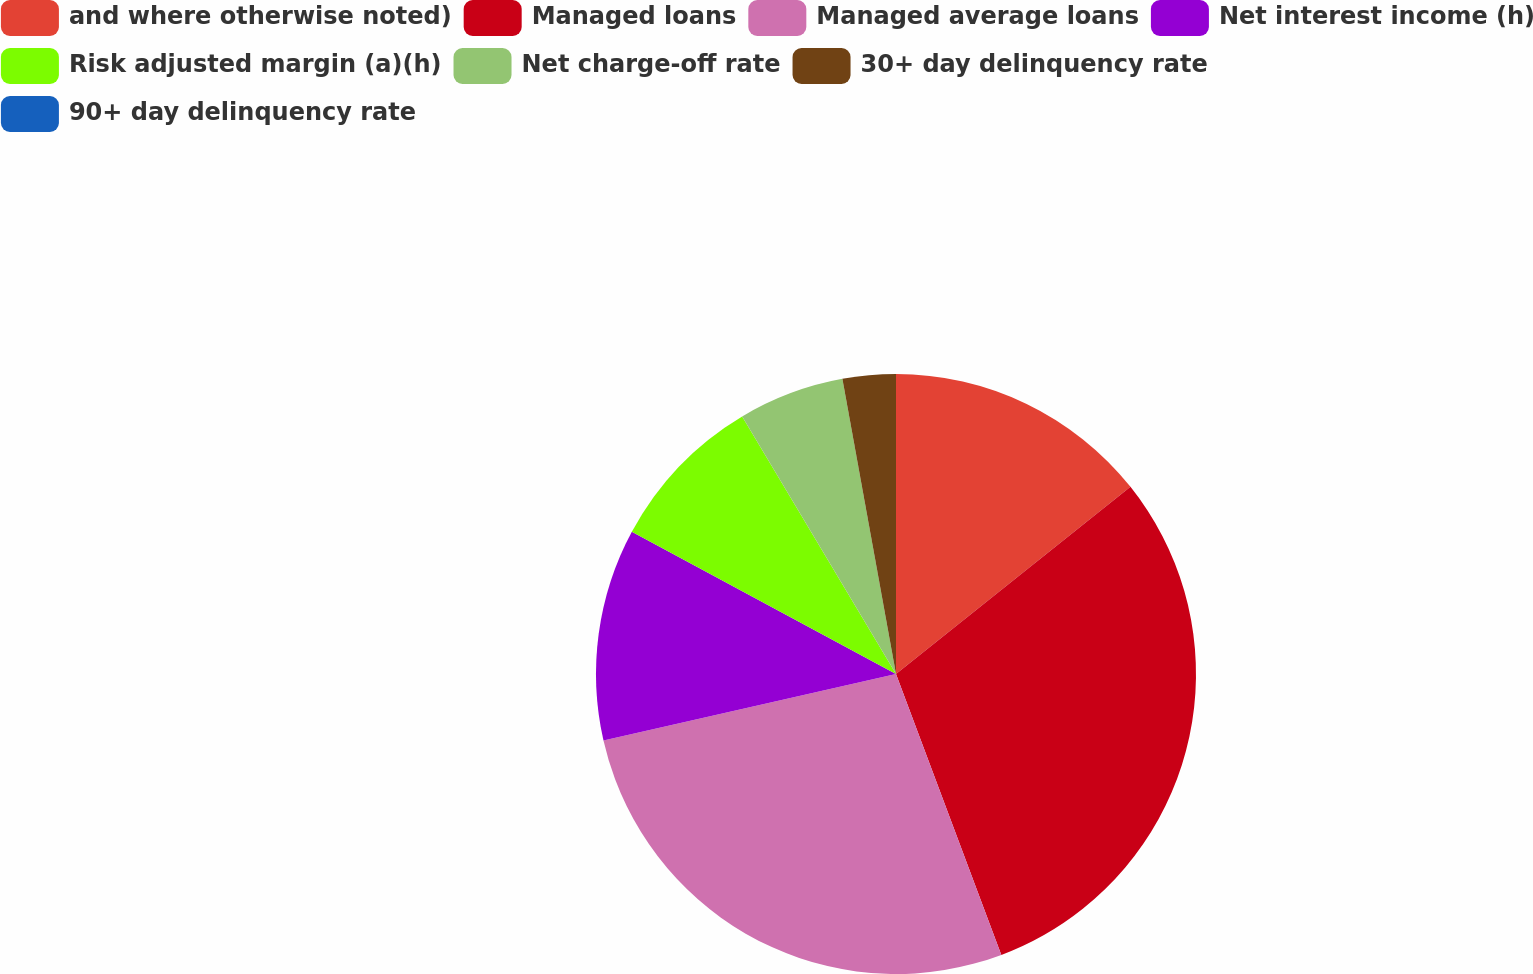<chart> <loc_0><loc_0><loc_500><loc_500><pie_chart><fcel>and where otherwise noted)<fcel>Managed loans<fcel>Managed average loans<fcel>Net interest income (h)<fcel>Risk adjusted margin (a)(h)<fcel>Net charge-off rate<fcel>30+ day delinquency rate<fcel>90+ day delinquency rate<nl><fcel>14.28%<fcel>30.01%<fcel>27.15%<fcel>11.42%<fcel>8.57%<fcel>5.71%<fcel>2.86%<fcel>0.0%<nl></chart> 